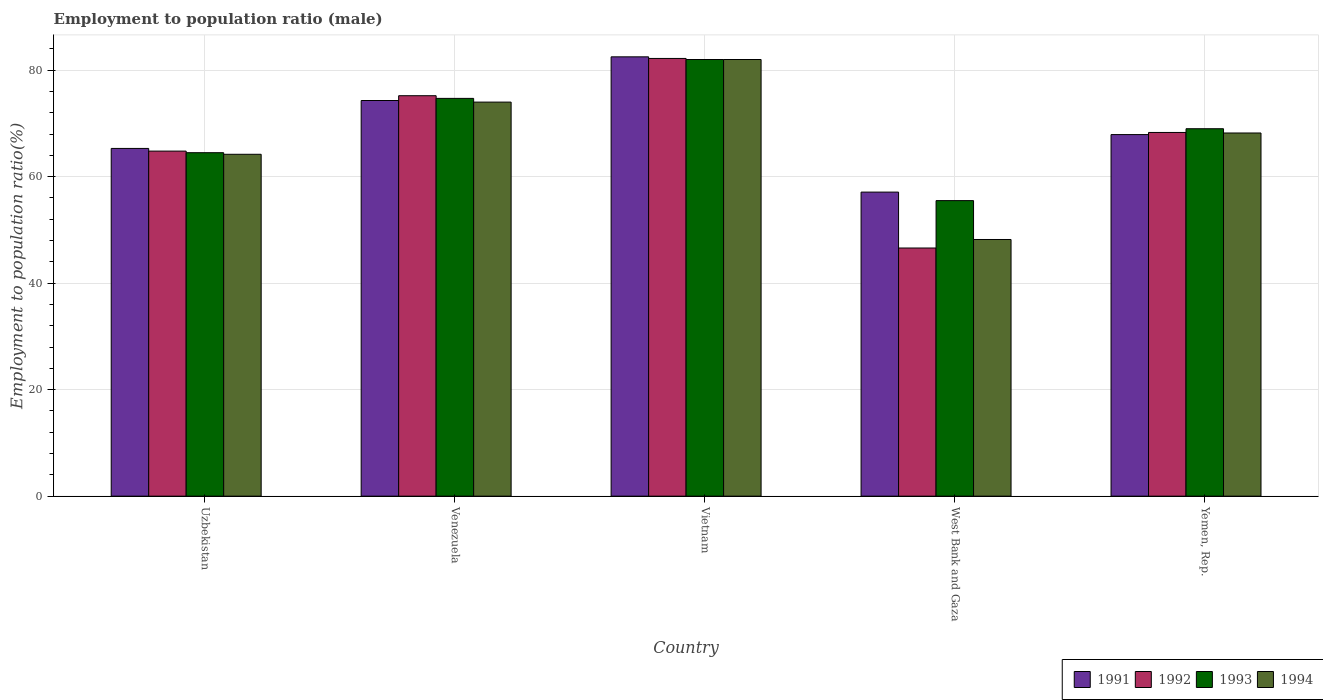Are the number of bars per tick equal to the number of legend labels?
Offer a terse response. Yes. Are the number of bars on each tick of the X-axis equal?
Offer a very short reply. Yes. What is the label of the 5th group of bars from the left?
Offer a terse response. Yemen, Rep. What is the employment to population ratio in 1993 in West Bank and Gaza?
Your answer should be compact. 55.5. Across all countries, what is the maximum employment to population ratio in 1994?
Your answer should be very brief. 82. Across all countries, what is the minimum employment to population ratio in 1991?
Your answer should be compact. 57.1. In which country was the employment to population ratio in 1991 maximum?
Ensure brevity in your answer.  Vietnam. In which country was the employment to population ratio in 1994 minimum?
Your answer should be compact. West Bank and Gaza. What is the total employment to population ratio in 1993 in the graph?
Your answer should be compact. 345.7. What is the difference between the employment to population ratio in 1992 in Uzbekistan and that in Vietnam?
Your answer should be compact. -17.4. What is the difference between the employment to population ratio in 1992 in Yemen, Rep. and the employment to population ratio in 1993 in Venezuela?
Make the answer very short. -6.4. What is the average employment to population ratio in 1994 per country?
Keep it short and to the point. 67.32. What is the difference between the employment to population ratio of/in 1992 and employment to population ratio of/in 1994 in Yemen, Rep.?
Your answer should be compact. 0.1. In how many countries, is the employment to population ratio in 1994 greater than 80 %?
Give a very brief answer. 1. What is the ratio of the employment to population ratio in 1993 in Venezuela to that in Yemen, Rep.?
Your response must be concise. 1.08. Is the employment to population ratio in 1991 in Venezuela less than that in Vietnam?
Offer a terse response. Yes. What is the difference between the highest and the second highest employment to population ratio in 1991?
Keep it short and to the point. 14.6. What is the difference between the highest and the lowest employment to population ratio in 1991?
Provide a succinct answer. 25.4. In how many countries, is the employment to population ratio in 1993 greater than the average employment to population ratio in 1993 taken over all countries?
Keep it short and to the point. 2. Is the sum of the employment to population ratio in 1992 in Uzbekistan and Yemen, Rep. greater than the maximum employment to population ratio in 1993 across all countries?
Your response must be concise. Yes. What does the 1st bar from the left in Vietnam represents?
Give a very brief answer. 1991. How many bars are there?
Ensure brevity in your answer.  20. Are all the bars in the graph horizontal?
Your answer should be very brief. No. What is the difference between two consecutive major ticks on the Y-axis?
Ensure brevity in your answer.  20. Are the values on the major ticks of Y-axis written in scientific E-notation?
Provide a short and direct response. No. Does the graph contain any zero values?
Provide a short and direct response. No. Does the graph contain grids?
Ensure brevity in your answer.  Yes. Where does the legend appear in the graph?
Your response must be concise. Bottom right. How many legend labels are there?
Your response must be concise. 4. How are the legend labels stacked?
Ensure brevity in your answer.  Horizontal. What is the title of the graph?
Give a very brief answer. Employment to population ratio (male). Does "1973" appear as one of the legend labels in the graph?
Provide a short and direct response. No. What is the label or title of the Y-axis?
Provide a short and direct response. Employment to population ratio(%). What is the Employment to population ratio(%) of 1991 in Uzbekistan?
Offer a terse response. 65.3. What is the Employment to population ratio(%) of 1992 in Uzbekistan?
Your response must be concise. 64.8. What is the Employment to population ratio(%) in 1993 in Uzbekistan?
Ensure brevity in your answer.  64.5. What is the Employment to population ratio(%) in 1994 in Uzbekistan?
Give a very brief answer. 64.2. What is the Employment to population ratio(%) of 1991 in Venezuela?
Make the answer very short. 74.3. What is the Employment to population ratio(%) in 1992 in Venezuela?
Your answer should be compact. 75.2. What is the Employment to population ratio(%) in 1993 in Venezuela?
Provide a short and direct response. 74.7. What is the Employment to population ratio(%) in 1994 in Venezuela?
Keep it short and to the point. 74. What is the Employment to population ratio(%) in 1991 in Vietnam?
Provide a short and direct response. 82.5. What is the Employment to population ratio(%) in 1992 in Vietnam?
Your answer should be compact. 82.2. What is the Employment to population ratio(%) of 1993 in Vietnam?
Offer a very short reply. 82. What is the Employment to population ratio(%) in 1994 in Vietnam?
Keep it short and to the point. 82. What is the Employment to population ratio(%) in 1991 in West Bank and Gaza?
Your answer should be compact. 57.1. What is the Employment to population ratio(%) in 1992 in West Bank and Gaza?
Provide a succinct answer. 46.6. What is the Employment to population ratio(%) in 1993 in West Bank and Gaza?
Give a very brief answer. 55.5. What is the Employment to population ratio(%) of 1994 in West Bank and Gaza?
Offer a very short reply. 48.2. What is the Employment to population ratio(%) of 1991 in Yemen, Rep.?
Your response must be concise. 67.9. What is the Employment to population ratio(%) of 1992 in Yemen, Rep.?
Provide a short and direct response. 68.3. What is the Employment to population ratio(%) of 1993 in Yemen, Rep.?
Provide a succinct answer. 69. What is the Employment to population ratio(%) of 1994 in Yemen, Rep.?
Offer a terse response. 68.2. Across all countries, what is the maximum Employment to population ratio(%) in 1991?
Give a very brief answer. 82.5. Across all countries, what is the maximum Employment to population ratio(%) of 1992?
Give a very brief answer. 82.2. Across all countries, what is the maximum Employment to population ratio(%) of 1993?
Provide a short and direct response. 82. Across all countries, what is the maximum Employment to population ratio(%) of 1994?
Provide a succinct answer. 82. Across all countries, what is the minimum Employment to population ratio(%) of 1991?
Your answer should be compact. 57.1. Across all countries, what is the minimum Employment to population ratio(%) in 1992?
Offer a terse response. 46.6. Across all countries, what is the minimum Employment to population ratio(%) in 1993?
Offer a terse response. 55.5. Across all countries, what is the minimum Employment to population ratio(%) of 1994?
Provide a succinct answer. 48.2. What is the total Employment to population ratio(%) of 1991 in the graph?
Your answer should be compact. 347.1. What is the total Employment to population ratio(%) of 1992 in the graph?
Provide a short and direct response. 337.1. What is the total Employment to population ratio(%) in 1993 in the graph?
Offer a very short reply. 345.7. What is the total Employment to population ratio(%) in 1994 in the graph?
Offer a terse response. 336.6. What is the difference between the Employment to population ratio(%) in 1994 in Uzbekistan and that in Venezuela?
Your answer should be very brief. -9.8. What is the difference between the Employment to population ratio(%) of 1991 in Uzbekistan and that in Vietnam?
Your response must be concise. -17.2. What is the difference between the Employment to population ratio(%) of 1992 in Uzbekistan and that in Vietnam?
Offer a very short reply. -17.4. What is the difference between the Employment to population ratio(%) in 1993 in Uzbekistan and that in Vietnam?
Offer a terse response. -17.5. What is the difference between the Employment to population ratio(%) in 1994 in Uzbekistan and that in Vietnam?
Your response must be concise. -17.8. What is the difference between the Employment to population ratio(%) of 1991 in Uzbekistan and that in West Bank and Gaza?
Your response must be concise. 8.2. What is the difference between the Employment to population ratio(%) of 1994 in Uzbekistan and that in West Bank and Gaza?
Give a very brief answer. 16. What is the difference between the Employment to population ratio(%) in 1991 in Uzbekistan and that in Yemen, Rep.?
Your response must be concise. -2.6. What is the difference between the Employment to population ratio(%) of 1992 in Uzbekistan and that in Yemen, Rep.?
Provide a short and direct response. -3.5. What is the difference between the Employment to population ratio(%) in 1994 in Uzbekistan and that in Yemen, Rep.?
Offer a terse response. -4. What is the difference between the Employment to population ratio(%) of 1991 in Venezuela and that in Vietnam?
Your answer should be very brief. -8.2. What is the difference between the Employment to population ratio(%) in 1992 in Venezuela and that in Vietnam?
Offer a terse response. -7. What is the difference between the Employment to population ratio(%) of 1993 in Venezuela and that in Vietnam?
Provide a succinct answer. -7.3. What is the difference between the Employment to population ratio(%) of 1991 in Venezuela and that in West Bank and Gaza?
Provide a short and direct response. 17.2. What is the difference between the Employment to population ratio(%) of 1992 in Venezuela and that in West Bank and Gaza?
Provide a succinct answer. 28.6. What is the difference between the Employment to population ratio(%) in 1994 in Venezuela and that in West Bank and Gaza?
Make the answer very short. 25.8. What is the difference between the Employment to population ratio(%) in 1993 in Venezuela and that in Yemen, Rep.?
Keep it short and to the point. 5.7. What is the difference between the Employment to population ratio(%) of 1994 in Venezuela and that in Yemen, Rep.?
Keep it short and to the point. 5.8. What is the difference between the Employment to population ratio(%) in 1991 in Vietnam and that in West Bank and Gaza?
Offer a terse response. 25.4. What is the difference between the Employment to population ratio(%) in 1992 in Vietnam and that in West Bank and Gaza?
Ensure brevity in your answer.  35.6. What is the difference between the Employment to population ratio(%) of 1993 in Vietnam and that in West Bank and Gaza?
Keep it short and to the point. 26.5. What is the difference between the Employment to population ratio(%) of 1994 in Vietnam and that in West Bank and Gaza?
Your answer should be compact. 33.8. What is the difference between the Employment to population ratio(%) of 1992 in Vietnam and that in Yemen, Rep.?
Your answer should be compact. 13.9. What is the difference between the Employment to population ratio(%) in 1994 in Vietnam and that in Yemen, Rep.?
Keep it short and to the point. 13.8. What is the difference between the Employment to population ratio(%) of 1992 in West Bank and Gaza and that in Yemen, Rep.?
Provide a succinct answer. -21.7. What is the difference between the Employment to population ratio(%) in 1993 in West Bank and Gaza and that in Yemen, Rep.?
Your answer should be compact. -13.5. What is the difference between the Employment to population ratio(%) in 1994 in West Bank and Gaza and that in Yemen, Rep.?
Provide a succinct answer. -20. What is the difference between the Employment to population ratio(%) of 1991 in Uzbekistan and the Employment to population ratio(%) of 1993 in Venezuela?
Make the answer very short. -9.4. What is the difference between the Employment to population ratio(%) of 1991 in Uzbekistan and the Employment to population ratio(%) of 1994 in Venezuela?
Provide a succinct answer. -8.7. What is the difference between the Employment to population ratio(%) of 1992 in Uzbekistan and the Employment to population ratio(%) of 1993 in Venezuela?
Offer a terse response. -9.9. What is the difference between the Employment to population ratio(%) in 1993 in Uzbekistan and the Employment to population ratio(%) in 1994 in Venezuela?
Your answer should be compact. -9.5. What is the difference between the Employment to population ratio(%) in 1991 in Uzbekistan and the Employment to population ratio(%) in 1992 in Vietnam?
Make the answer very short. -16.9. What is the difference between the Employment to population ratio(%) in 1991 in Uzbekistan and the Employment to population ratio(%) in 1993 in Vietnam?
Offer a terse response. -16.7. What is the difference between the Employment to population ratio(%) of 1991 in Uzbekistan and the Employment to population ratio(%) of 1994 in Vietnam?
Offer a terse response. -16.7. What is the difference between the Employment to population ratio(%) of 1992 in Uzbekistan and the Employment to population ratio(%) of 1993 in Vietnam?
Your response must be concise. -17.2. What is the difference between the Employment to population ratio(%) in 1992 in Uzbekistan and the Employment to population ratio(%) in 1994 in Vietnam?
Your answer should be very brief. -17.2. What is the difference between the Employment to population ratio(%) of 1993 in Uzbekistan and the Employment to population ratio(%) of 1994 in Vietnam?
Keep it short and to the point. -17.5. What is the difference between the Employment to population ratio(%) in 1991 in Uzbekistan and the Employment to population ratio(%) in 1992 in West Bank and Gaza?
Provide a succinct answer. 18.7. What is the difference between the Employment to population ratio(%) of 1991 in Uzbekistan and the Employment to population ratio(%) of 1994 in West Bank and Gaza?
Give a very brief answer. 17.1. What is the difference between the Employment to population ratio(%) of 1992 in Uzbekistan and the Employment to population ratio(%) of 1993 in West Bank and Gaza?
Offer a terse response. 9.3. What is the difference between the Employment to population ratio(%) in 1992 in Uzbekistan and the Employment to population ratio(%) in 1994 in West Bank and Gaza?
Provide a succinct answer. 16.6. What is the difference between the Employment to population ratio(%) of 1993 in Uzbekistan and the Employment to population ratio(%) of 1994 in West Bank and Gaza?
Keep it short and to the point. 16.3. What is the difference between the Employment to population ratio(%) in 1992 in Uzbekistan and the Employment to population ratio(%) in 1993 in Yemen, Rep.?
Make the answer very short. -4.2. What is the difference between the Employment to population ratio(%) of 1993 in Uzbekistan and the Employment to population ratio(%) of 1994 in Yemen, Rep.?
Your answer should be compact. -3.7. What is the difference between the Employment to population ratio(%) of 1991 in Venezuela and the Employment to population ratio(%) of 1993 in Vietnam?
Give a very brief answer. -7.7. What is the difference between the Employment to population ratio(%) in 1992 in Venezuela and the Employment to population ratio(%) in 1994 in Vietnam?
Offer a terse response. -6.8. What is the difference between the Employment to population ratio(%) of 1993 in Venezuela and the Employment to population ratio(%) of 1994 in Vietnam?
Keep it short and to the point. -7.3. What is the difference between the Employment to population ratio(%) of 1991 in Venezuela and the Employment to population ratio(%) of 1992 in West Bank and Gaza?
Ensure brevity in your answer.  27.7. What is the difference between the Employment to population ratio(%) of 1991 in Venezuela and the Employment to population ratio(%) of 1994 in West Bank and Gaza?
Provide a succinct answer. 26.1. What is the difference between the Employment to population ratio(%) in 1993 in Venezuela and the Employment to population ratio(%) in 1994 in West Bank and Gaza?
Give a very brief answer. 26.5. What is the difference between the Employment to population ratio(%) in 1991 in Venezuela and the Employment to population ratio(%) in 1993 in Yemen, Rep.?
Offer a terse response. 5.3. What is the difference between the Employment to population ratio(%) of 1991 in Venezuela and the Employment to population ratio(%) of 1994 in Yemen, Rep.?
Your answer should be compact. 6.1. What is the difference between the Employment to population ratio(%) of 1992 in Venezuela and the Employment to population ratio(%) of 1994 in Yemen, Rep.?
Offer a very short reply. 7. What is the difference between the Employment to population ratio(%) in 1993 in Venezuela and the Employment to population ratio(%) in 1994 in Yemen, Rep.?
Your answer should be very brief. 6.5. What is the difference between the Employment to population ratio(%) in 1991 in Vietnam and the Employment to population ratio(%) in 1992 in West Bank and Gaza?
Give a very brief answer. 35.9. What is the difference between the Employment to population ratio(%) in 1991 in Vietnam and the Employment to population ratio(%) in 1993 in West Bank and Gaza?
Offer a terse response. 27. What is the difference between the Employment to population ratio(%) in 1991 in Vietnam and the Employment to population ratio(%) in 1994 in West Bank and Gaza?
Ensure brevity in your answer.  34.3. What is the difference between the Employment to population ratio(%) of 1992 in Vietnam and the Employment to population ratio(%) of 1993 in West Bank and Gaza?
Keep it short and to the point. 26.7. What is the difference between the Employment to population ratio(%) in 1992 in Vietnam and the Employment to population ratio(%) in 1994 in West Bank and Gaza?
Offer a very short reply. 34. What is the difference between the Employment to population ratio(%) in 1993 in Vietnam and the Employment to population ratio(%) in 1994 in West Bank and Gaza?
Your response must be concise. 33.8. What is the difference between the Employment to population ratio(%) in 1991 in Vietnam and the Employment to population ratio(%) in 1994 in Yemen, Rep.?
Ensure brevity in your answer.  14.3. What is the difference between the Employment to population ratio(%) in 1993 in Vietnam and the Employment to population ratio(%) in 1994 in Yemen, Rep.?
Give a very brief answer. 13.8. What is the difference between the Employment to population ratio(%) of 1991 in West Bank and Gaza and the Employment to population ratio(%) of 1992 in Yemen, Rep.?
Your answer should be compact. -11.2. What is the difference between the Employment to population ratio(%) of 1992 in West Bank and Gaza and the Employment to population ratio(%) of 1993 in Yemen, Rep.?
Make the answer very short. -22.4. What is the difference between the Employment to population ratio(%) in 1992 in West Bank and Gaza and the Employment to population ratio(%) in 1994 in Yemen, Rep.?
Your answer should be compact. -21.6. What is the average Employment to population ratio(%) of 1991 per country?
Make the answer very short. 69.42. What is the average Employment to population ratio(%) in 1992 per country?
Your response must be concise. 67.42. What is the average Employment to population ratio(%) of 1993 per country?
Offer a very short reply. 69.14. What is the average Employment to population ratio(%) of 1994 per country?
Give a very brief answer. 67.32. What is the difference between the Employment to population ratio(%) of 1991 and Employment to population ratio(%) of 1993 in Uzbekistan?
Your answer should be compact. 0.8. What is the difference between the Employment to population ratio(%) of 1992 and Employment to population ratio(%) of 1994 in Uzbekistan?
Offer a terse response. 0.6. What is the difference between the Employment to population ratio(%) in 1993 and Employment to population ratio(%) in 1994 in Uzbekistan?
Your response must be concise. 0.3. What is the difference between the Employment to population ratio(%) of 1991 and Employment to population ratio(%) of 1992 in Venezuela?
Offer a terse response. -0.9. What is the difference between the Employment to population ratio(%) of 1991 and Employment to population ratio(%) of 1993 in Venezuela?
Offer a very short reply. -0.4. What is the difference between the Employment to population ratio(%) of 1991 and Employment to population ratio(%) of 1994 in Venezuela?
Your answer should be compact. 0.3. What is the difference between the Employment to population ratio(%) of 1993 and Employment to population ratio(%) of 1994 in Venezuela?
Give a very brief answer. 0.7. What is the difference between the Employment to population ratio(%) of 1992 and Employment to population ratio(%) of 1993 in Vietnam?
Your answer should be very brief. 0.2. What is the difference between the Employment to population ratio(%) in 1992 and Employment to population ratio(%) in 1994 in Vietnam?
Your response must be concise. 0.2. What is the difference between the Employment to population ratio(%) of 1991 and Employment to population ratio(%) of 1993 in West Bank and Gaza?
Make the answer very short. 1.6. What is the difference between the Employment to population ratio(%) of 1992 and Employment to population ratio(%) of 1994 in West Bank and Gaza?
Your answer should be compact. -1.6. What is the difference between the Employment to population ratio(%) in 1993 and Employment to population ratio(%) in 1994 in West Bank and Gaza?
Provide a succinct answer. 7.3. What is the difference between the Employment to population ratio(%) in 1991 and Employment to population ratio(%) in 1992 in Yemen, Rep.?
Give a very brief answer. -0.4. What is the difference between the Employment to population ratio(%) of 1992 and Employment to population ratio(%) of 1993 in Yemen, Rep.?
Keep it short and to the point. -0.7. What is the difference between the Employment to population ratio(%) in 1993 and Employment to population ratio(%) in 1994 in Yemen, Rep.?
Provide a succinct answer. 0.8. What is the ratio of the Employment to population ratio(%) in 1991 in Uzbekistan to that in Venezuela?
Provide a short and direct response. 0.88. What is the ratio of the Employment to population ratio(%) of 1992 in Uzbekistan to that in Venezuela?
Your answer should be compact. 0.86. What is the ratio of the Employment to population ratio(%) in 1993 in Uzbekistan to that in Venezuela?
Give a very brief answer. 0.86. What is the ratio of the Employment to population ratio(%) in 1994 in Uzbekistan to that in Venezuela?
Make the answer very short. 0.87. What is the ratio of the Employment to population ratio(%) of 1991 in Uzbekistan to that in Vietnam?
Your answer should be compact. 0.79. What is the ratio of the Employment to population ratio(%) in 1992 in Uzbekistan to that in Vietnam?
Offer a very short reply. 0.79. What is the ratio of the Employment to population ratio(%) in 1993 in Uzbekistan to that in Vietnam?
Your answer should be very brief. 0.79. What is the ratio of the Employment to population ratio(%) of 1994 in Uzbekistan to that in Vietnam?
Keep it short and to the point. 0.78. What is the ratio of the Employment to population ratio(%) in 1991 in Uzbekistan to that in West Bank and Gaza?
Ensure brevity in your answer.  1.14. What is the ratio of the Employment to population ratio(%) in 1992 in Uzbekistan to that in West Bank and Gaza?
Your response must be concise. 1.39. What is the ratio of the Employment to population ratio(%) in 1993 in Uzbekistan to that in West Bank and Gaza?
Provide a short and direct response. 1.16. What is the ratio of the Employment to population ratio(%) in 1994 in Uzbekistan to that in West Bank and Gaza?
Give a very brief answer. 1.33. What is the ratio of the Employment to population ratio(%) in 1991 in Uzbekistan to that in Yemen, Rep.?
Keep it short and to the point. 0.96. What is the ratio of the Employment to population ratio(%) in 1992 in Uzbekistan to that in Yemen, Rep.?
Make the answer very short. 0.95. What is the ratio of the Employment to population ratio(%) in 1993 in Uzbekistan to that in Yemen, Rep.?
Your response must be concise. 0.93. What is the ratio of the Employment to population ratio(%) of 1994 in Uzbekistan to that in Yemen, Rep.?
Make the answer very short. 0.94. What is the ratio of the Employment to population ratio(%) of 1991 in Venezuela to that in Vietnam?
Ensure brevity in your answer.  0.9. What is the ratio of the Employment to population ratio(%) of 1992 in Venezuela to that in Vietnam?
Offer a very short reply. 0.91. What is the ratio of the Employment to population ratio(%) of 1993 in Venezuela to that in Vietnam?
Provide a succinct answer. 0.91. What is the ratio of the Employment to population ratio(%) of 1994 in Venezuela to that in Vietnam?
Keep it short and to the point. 0.9. What is the ratio of the Employment to population ratio(%) in 1991 in Venezuela to that in West Bank and Gaza?
Your response must be concise. 1.3. What is the ratio of the Employment to population ratio(%) of 1992 in Venezuela to that in West Bank and Gaza?
Provide a succinct answer. 1.61. What is the ratio of the Employment to population ratio(%) of 1993 in Venezuela to that in West Bank and Gaza?
Offer a very short reply. 1.35. What is the ratio of the Employment to population ratio(%) of 1994 in Venezuela to that in West Bank and Gaza?
Ensure brevity in your answer.  1.54. What is the ratio of the Employment to population ratio(%) in 1991 in Venezuela to that in Yemen, Rep.?
Provide a short and direct response. 1.09. What is the ratio of the Employment to population ratio(%) of 1992 in Venezuela to that in Yemen, Rep.?
Give a very brief answer. 1.1. What is the ratio of the Employment to population ratio(%) of 1993 in Venezuela to that in Yemen, Rep.?
Ensure brevity in your answer.  1.08. What is the ratio of the Employment to population ratio(%) of 1994 in Venezuela to that in Yemen, Rep.?
Your answer should be compact. 1.08. What is the ratio of the Employment to population ratio(%) in 1991 in Vietnam to that in West Bank and Gaza?
Your response must be concise. 1.44. What is the ratio of the Employment to population ratio(%) in 1992 in Vietnam to that in West Bank and Gaza?
Your answer should be very brief. 1.76. What is the ratio of the Employment to population ratio(%) of 1993 in Vietnam to that in West Bank and Gaza?
Offer a terse response. 1.48. What is the ratio of the Employment to population ratio(%) of 1994 in Vietnam to that in West Bank and Gaza?
Make the answer very short. 1.7. What is the ratio of the Employment to population ratio(%) of 1991 in Vietnam to that in Yemen, Rep.?
Provide a succinct answer. 1.22. What is the ratio of the Employment to population ratio(%) in 1992 in Vietnam to that in Yemen, Rep.?
Your answer should be compact. 1.2. What is the ratio of the Employment to population ratio(%) of 1993 in Vietnam to that in Yemen, Rep.?
Ensure brevity in your answer.  1.19. What is the ratio of the Employment to population ratio(%) of 1994 in Vietnam to that in Yemen, Rep.?
Give a very brief answer. 1.2. What is the ratio of the Employment to population ratio(%) in 1991 in West Bank and Gaza to that in Yemen, Rep.?
Give a very brief answer. 0.84. What is the ratio of the Employment to population ratio(%) in 1992 in West Bank and Gaza to that in Yemen, Rep.?
Provide a short and direct response. 0.68. What is the ratio of the Employment to population ratio(%) in 1993 in West Bank and Gaza to that in Yemen, Rep.?
Keep it short and to the point. 0.8. What is the ratio of the Employment to population ratio(%) in 1994 in West Bank and Gaza to that in Yemen, Rep.?
Provide a succinct answer. 0.71. What is the difference between the highest and the second highest Employment to population ratio(%) of 1991?
Offer a very short reply. 8.2. What is the difference between the highest and the second highest Employment to population ratio(%) of 1993?
Offer a terse response. 7.3. What is the difference between the highest and the lowest Employment to population ratio(%) of 1991?
Provide a short and direct response. 25.4. What is the difference between the highest and the lowest Employment to population ratio(%) of 1992?
Keep it short and to the point. 35.6. What is the difference between the highest and the lowest Employment to population ratio(%) of 1993?
Ensure brevity in your answer.  26.5. What is the difference between the highest and the lowest Employment to population ratio(%) of 1994?
Offer a very short reply. 33.8. 